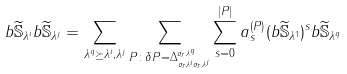<formula> <loc_0><loc_0><loc_500><loc_500>{ b } \widetilde { \mathbb { S } } _ { \lambda ^ { i } } { b } \widetilde { \mathbb { S } } _ { \lambda ^ { j } } & = \sum _ { \lambda ^ { q } \succeq \lambda ^ { i } , \lambda ^ { j } } \sum _ { P \colon \delta P = \Delta _ { \sigma _ { r } \lambda ^ { i } \sigma _ { r } \lambda ^ { j } } ^ { \sigma _ { r } \lambda ^ { q } } } \sum _ { s = 0 } ^ { | P | } a ^ { ( P ) } _ { s } ( { b } \widetilde { \mathbb { S } } _ { \lambda ^ { 1 } } ) ^ { s } { b } \widetilde { \mathbb { S } } _ { \lambda ^ { q } } \\</formula> 